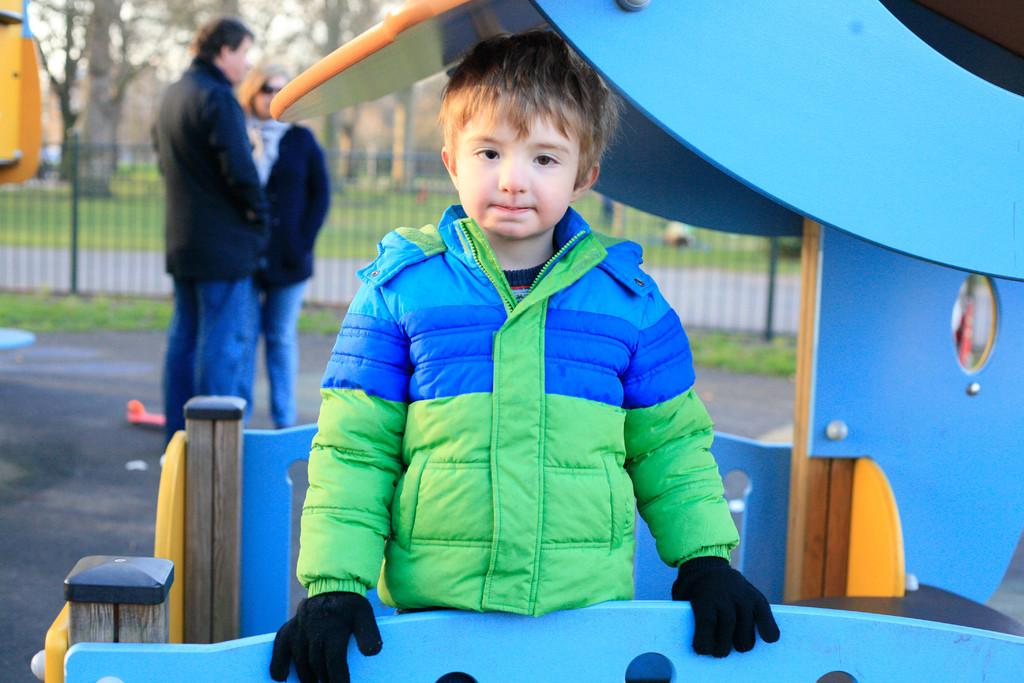What is the main subject of the image? The main subject of the image is a kid. What is the kid wearing? The kid is wearing a blue and green jacket. What is the kid's posture in the image? The kid is standing. Are there any other people in the image? Yes, there are two other persons standing behind the kid. What can be seen in the background of the image? There are trees in the background of the image. What type of fuel is being used by the cherry in the image? There is no cherry present in the image, so the question about fuel is not applicable. 